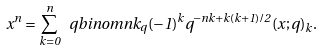<formula> <loc_0><loc_0><loc_500><loc_500>x ^ { n } = \sum _ { k = 0 } ^ { n } \ q b i n o m { n } { k } _ { q } ( - 1 ) ^ { k } q ^ { - n k + k ( k + 1 ) / 2 } ( x ; q ) _ { k } .</formula> 